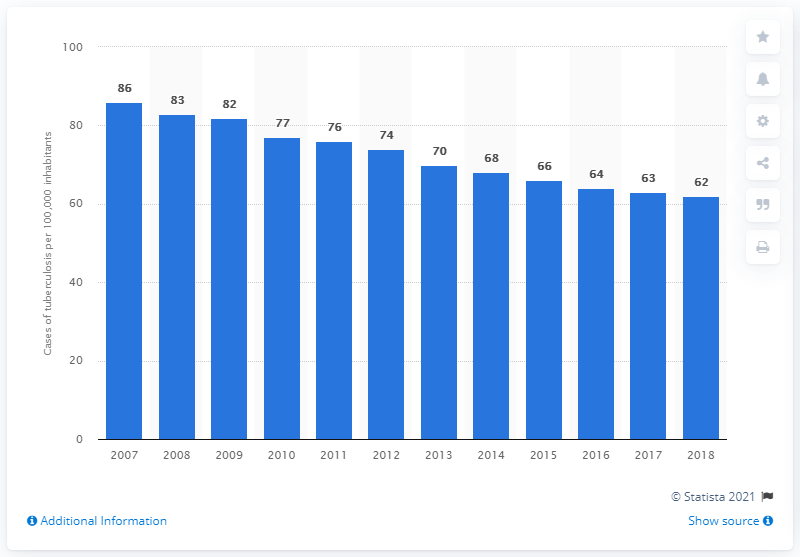Specify some key components in this picture. In 2018, an estimated 62 people out of every 100,000 inhabitants in China fell sick with tuberculosis. 